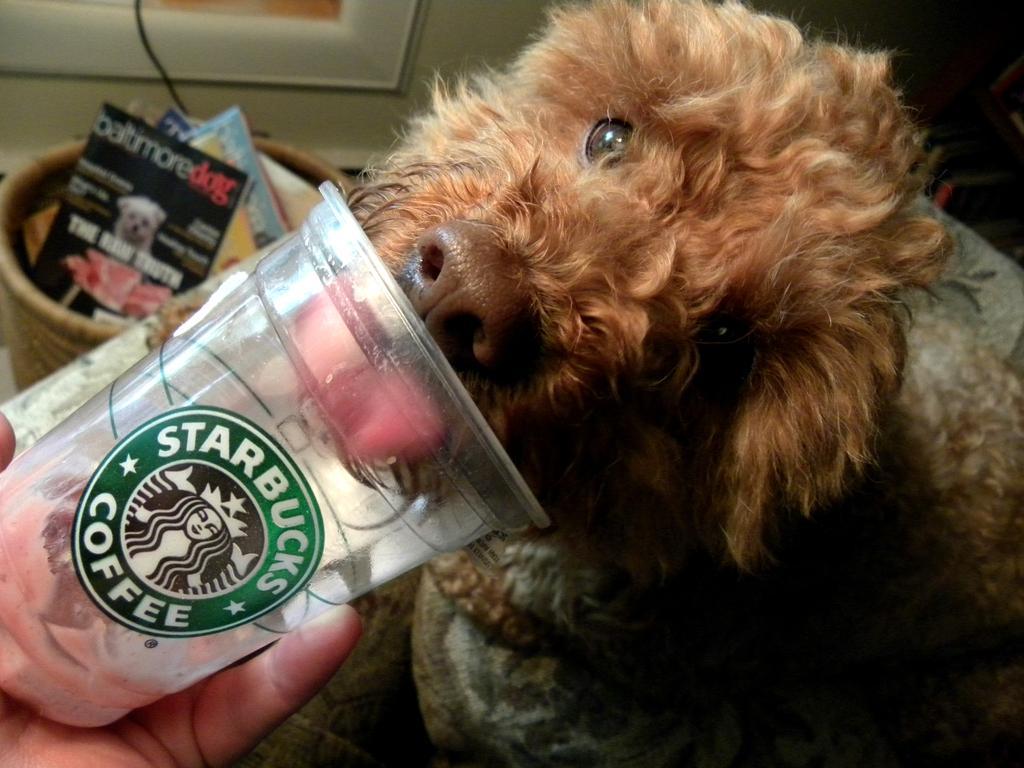In one or two sentences, can you explain what this image depicts? On the left side of the image I can see a person's hand holding a glass, on the glass I can see some text. On the right side there is an animal. In the background there is a basket in which I can see few books. At the top I can see the wall. 